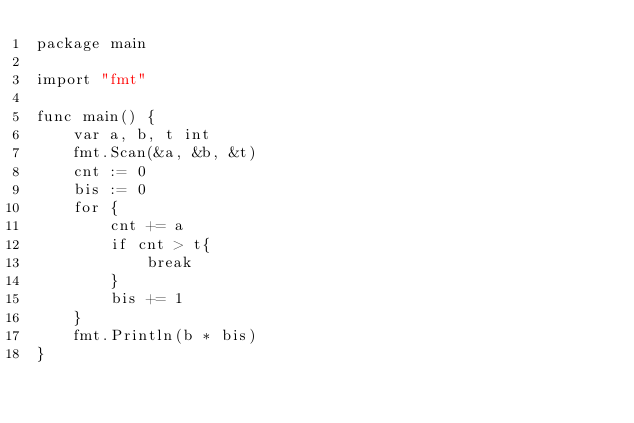<code> <loc_0><loc_0><loc_500><loc_500><_Go_>package main

import "fmt"

func main() {
	var a, b, t int
	fmt.Scan(&a, &b, &t)
	cnt := 0
	bis := 0
	for {
		cnt += a
		if cnt > t{
			break
		}
		bis += 1 
	}
	fmt.Println(b * bis)
}</code> 